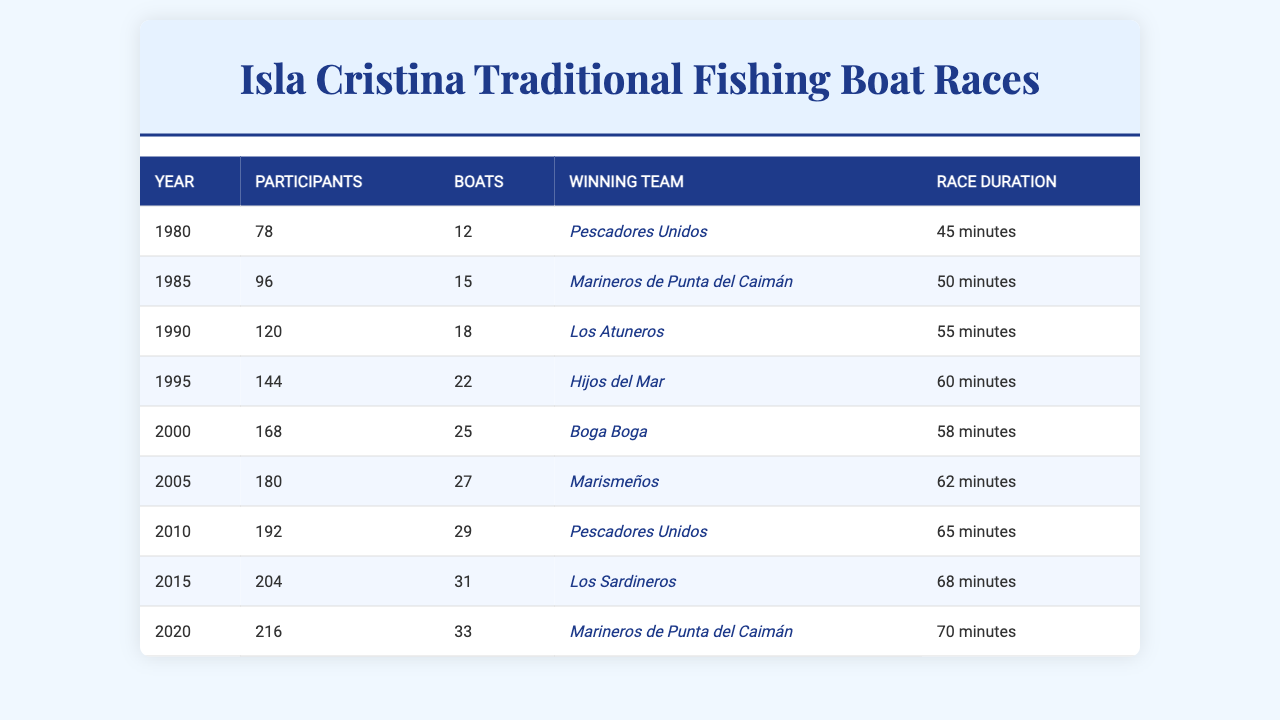What was the winning team in 2000? According to the table, the winning team in 2000 is "Boga Boga."
Answer: Boga Boga How many participants were there in 1995? The table indicates that there were 144 participants in 1995.
Answer: 144 In what year did the number of participants first exceed 200? The table shows that the number of participants first exceeded 200 in 2015, where there were 204 participants.
Answer: 2015 What is the difference in the number of participants between 1980 and 2020? The number of participants in 1980 was 78, and in 2020 it was 216. The difference is 216 - 78 = 138.
Answer: 138 What was the average number of boats from 1980 to 2020? Adding the number of boats from each year (12 + 15 + 18 + 22 + 25 + 27 + 29 + 31 + 33 = 212) gives a total of 212 boats. There are 9 years, so the average is 212 / 9 ≈ 23.56.
Answer: Approximately 23.56 How many minutes did the race last on average from 1980 to 2020? The total race duration is (45 + 50 + 55 + 60 + 58 + 62 + 65 + 68 + 70 = 490) minutes. Dividing by the number of years (9) gives an average of 490 / 9 ≈ 54.44.
Answer: Approximately 54.44 Was there a year when "Pescadores Unidos" won the race? Yes, the table shows that "Pescadores Unidos" won in 1980 and again in 2010.
Answer: Yes Which team won the most recent race in 2020? According to the table, the winning team in 2020 is "Marineros de Punta del Caimán."
Answer: Marineros de Punta del Caimán How many more boats were there in 2020 compared to 1985? The number of boats in 2020 was 33, and in 1985, it was 15. The difference is 33 - 15 = 18.
Answer: 18 In which year was the race duration the longest? The table indicates that the longest race duration was in 2020, lasting 70 minutes.
Answer: 2020 What was the total number of participants from 1980 to 2020? The total number of participants is the sum of all participants from each year: (78 + 96 + 120 + 144 + 168 + 180 + 192 + 204 + 216 = 1398).
Answer: 1398 